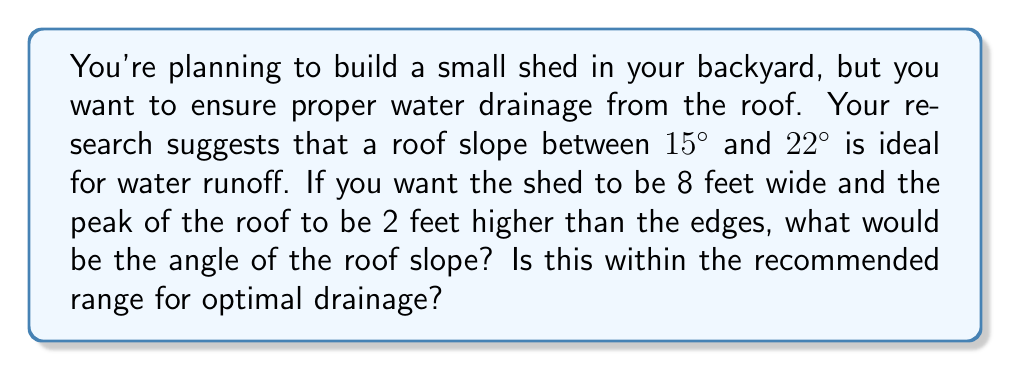Teach me how to tackle this problem. Let's approach this step-by-step:

1) First, we need to visualize the problem. The roof forms a right triangle, where:
   - Half the width of the shed is the base of the triangle
   - The height difference between the peak and edge is the height of the triangle
   - The roof slope forms the hypotenuse

2) We can represent this with a diagram:

[asy]
unitsize(30);
draw((0,0)--(4,0)--(4,2)--(0,0),black);
draw((4,0)--(8,0),dashed);
label("8 ft", (4,-0.3), S);
label("4 ft", (2,-0.2), N);
label("2 ft", (4.2,1), E);
label("θ", (0.5,0.3), NW);
[/asy]

3) We need to find the angle θ. We can use the tangent function for this:

   $$\tan(\theta) = \frac{\text{opposite}}{\text{adjacent}} = \frac{\text{height}}{\text{half width}}$$

4) We know:
   - Height = 2 feet
   - Half width = 4 feet (since total width is 8 feet)

5) Plugging these values into our equation:

   $$\tan(\theta) = \frac{2}{4} = \frac{1}{2} = 0.5$$

6) To find θ, we need to take the inverse tangent (arctan or tan^(-1)):

   $$\theta = \tan^{-1}(0.5)$$

7) Using a calculator or trigonometric tables:

   $$\theta \approx 26.57°$$

8) Comparing to the recommended range of 15° to 22°:
   26.57° is higher than the recommended maximum of 22°.
Answer: The angle of the roof slope is approximately 26.57°. This is not within the recommended range of 15° to 22° for optimal drainage; it's steeper than recommended. 